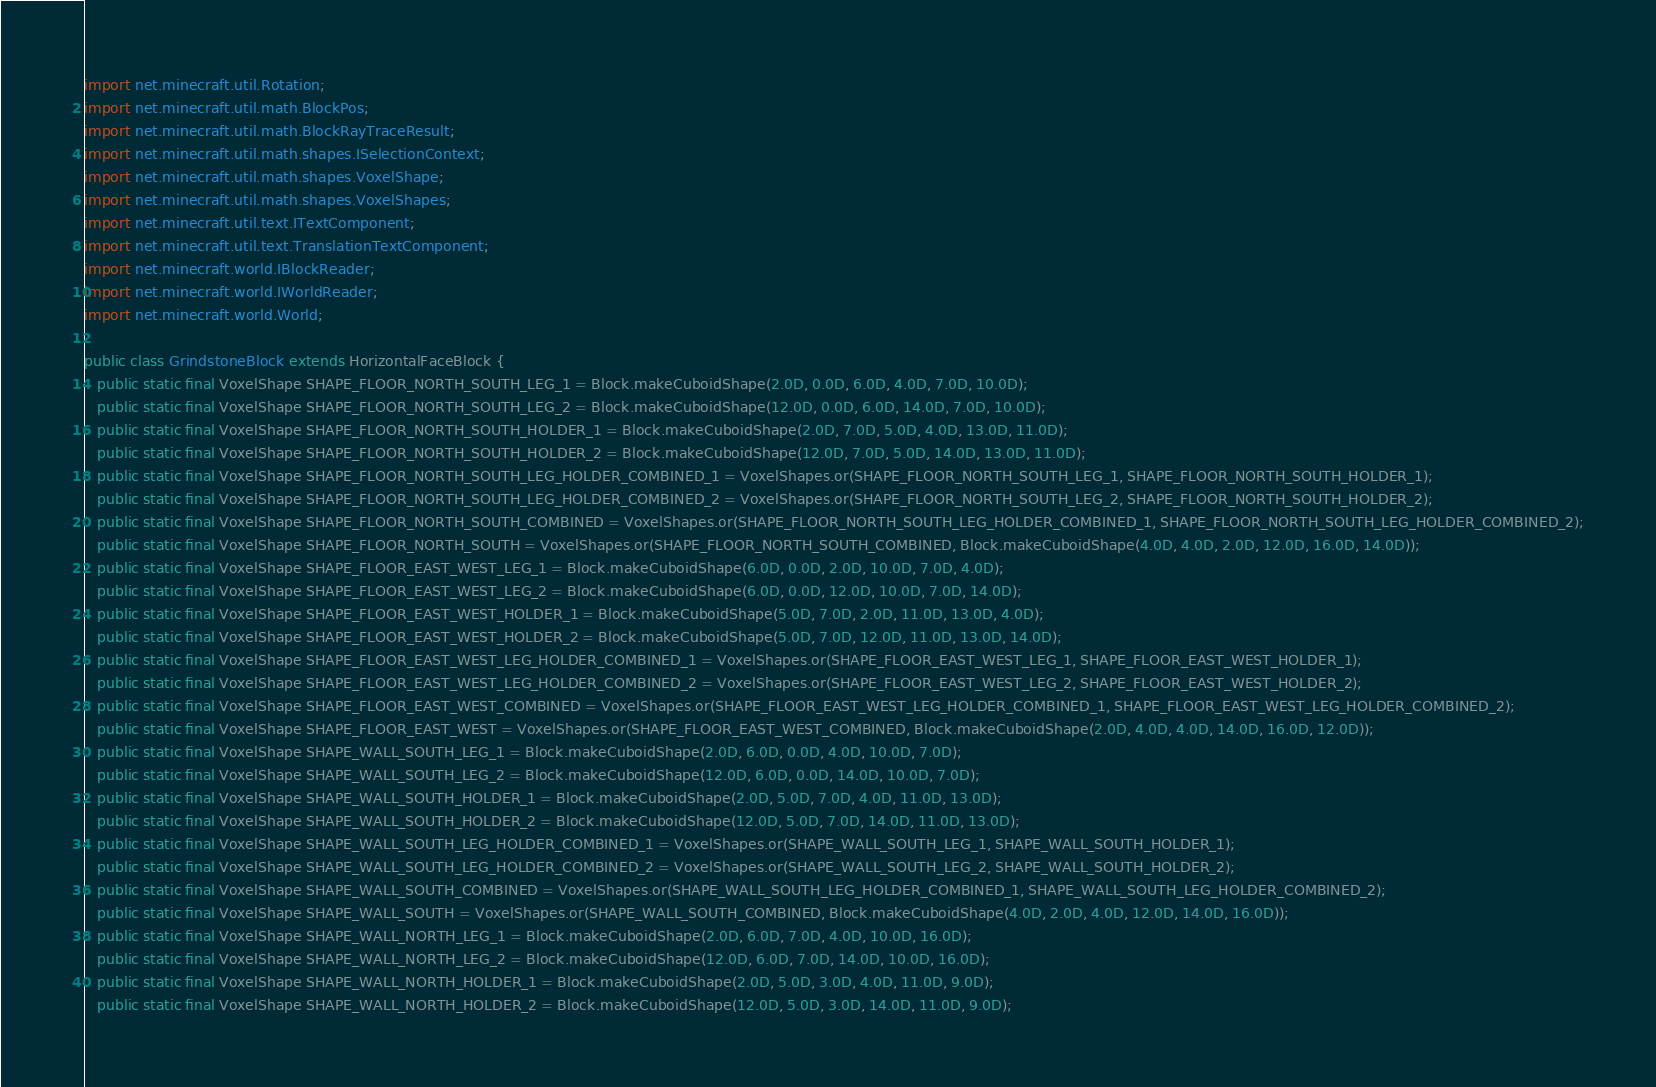Convert code to text. <code><loc_0><loc_0><loc_500><loc_500><_Java_>import net.minecraft.util.Rotation;
import net.minecraft.util.math.BlockPos;
import net.minecraft.util.math.BlockRayTraceResult;
import net.minecraft.util.math.shapes.ISelectionContext;
import net.minecraft.util.math.shapes.VoxelShape;
import net.minecraft.util.math.shapes.VoxelShapes;
import net.minecraft.util.text.ITextComponent;
import net.minecraft.util.text.TranslationTextComponent;
import net.minecraft.world.IBlockReader;
import net.minecraft.world.IWorldReader;
import net.minecraft.world.World;

public class GrindstoneBlock extends HorizontalFaceBlock {
   public static final VoxelShape SHAPE_FLOOR_NORTH_SOUTH_LEG_1 = Block.makeCuboidShape(2.0D, 0.0D, 6.0D, 4.0D, 7.0D, 10.0D);
   public static final VoxelShape SHAPE_FLOOR_NORTH_SOUTH_LEG_2 = Block.makeCuboidShape(12.0D, 0.0D, 6.0D, 14.0D, 7.0D, 10.0D);
   public static final VoxelShape SHAPE_FLOOR_NORTH_SOUTH_HOLDER_1 = Block.makeCuboidShape(2.0D, 7.0D, 5.0D, 4.0D, 13.0D, 11.0D);
   public static final VoxelShape SHAPE_FLOOR_NORTH_SOUTH_HOLDER_2 = Block.makeCuboidShape(12.0D, 7.0D, 5.0D, 14.0D, 13.0D, 11.0D);
   public static final VoxelShape SHAPE_FLOOR_NORTH_SOUTH_LEG_HOLDER_COMBINED_1 = VoxelShapes.or(SHAPE_FLOOR_NORTH_SOUTH_LEG_1, SHAPE_FLOOR_NORTH_SOUTH_HOLDER_1);
   public static final VoxelShape SHAPE_FLOOR_NORTH_SOUTH_LEG_HOLDER_COMBINED_2 = VoxelShapes.or(SHAPE_FLOOR_NORTH_SOUTH_LEG_2, SHAPE_FLOOR_NORTH_SOUTH_HOLDER_2);
   public static final VoxelShape SHAPE_FLOOR_NORTH_SOUTH_COMBINED = VoxelShapes.or(SHAPE_FLOOR_NORTH_SOUTH_LEG_HOLDER_COMBINED_1, SHAPE_FLOOR_NORTH_SOUTH_LEG_HOLDER_COMBINED_2);
   public static final VoxelShape SHAPE_FLOOR_NORTH_SOUTH = VoxelShapes.or(SHAPE_FLOOR_NORTH_SOUTH_COMBINED, Block.makeCuboidShape(4.0D, 4.0D, 2.0D, 12.0D, 16.0D, 14.0D));
   public static final VoxelShape SHAPE_FLOOR_EAST_WEST_LEG_1 = Block.makeCuboidShape(6.0D, 0.0D, 2.0D, 10.0D, 7.0D, 4.0D);
   public static final VoxelShape SHAPE_FLOOR_EAST_WEST_LEG_2 = Block.makeCuboidShape(6.0D, 0.0D, 12.0D, 10.0D, 7.0D, 14.0D);
   public static final VoxelShape SHAPE_FLOOR_EAST_WEST_HOLDER_1 = Block.makeCuboidShape(5.0D, 7.0D, 2.0D, 11.0D, 13.0D, 4.0D);
   public static final VoxelShape SHAPE_FLOOR_EAST_WEST_HOLDER_2 = Block.makeCuboidShape(5.0D, 7.0D, 12.0D, 11.0D, 13.0D, 14.0D);
   public static final VoxelShape SHAPE_FLOOR_EAST_WEST_LEG_HOLDER_COMBINED_1 = VoxelShapes.or(SHAPE_FLOOR_EAST_WEST_LEG_1, SHAPE_FLOOR_EAST_WEST_HOLDER_1);
   public static final VoxelShape SHAPE_FLOOR_EAST_WEST_LEG_HOLDER_COMBINED_2 = VoxelShapes.or(SHAPE_FLOOR_EAST_WEST_LEG_2, SHAPE_FLOOR_EAST_WEST_HOLDER_2);
   public static final VoxelShape SHAPE_FLOOR_EAST_WEST_COMBINED = VoxelShapes.or(SHAPE_FLOOR_EAST_WEST_LEG_HOLDER_COMBINED_1, SHAPE_FLOOR_EAST_WEST_LEG_HOLDER_COMBINED_2);
   public static final VoxelShape SHAPE_FLOOR_EAST_WEST = VoxelShapes.or(SHAPE_FLOOR_EAST_WEST_COMBINED, Block.makeCuboidShape(2.0D, 4.0D, 4.0D, 14.0D, 16.0D, 12.0D));
   public static final VoxelShape SHAPE_WALL_SOUTH_LEG_1 = Block.makeCuboidShape(2.0D, 6.0D, 0.0D, 4.0D, 10.0D, 7.0D);
   public static final VoxelShape SHAPE_WALL_SOUTH_LEG_2 = Block.makeCuboidShape(12.0D, 6.0D, 0.0D, 14.0D, 10.0D, 7.0D);
   public static final VoxelShape SHAPE_WALL_SOUTH_HOLDER_1 = Block.makeCuboidShape(2.0D, 5.0D, 7.0D, 4.0D, 11.0D, 13.0D);
   public static final VoxelShape SHAPE_WALL_SOUTH_HOLDER_2 = Block.makeCuboidShape(12.0D, 5.0D, 7.0D, 14.0D, 11.0D, 13.0D);
   public static final VoxelShape SHAPE_WALL_SOUTH_LEG_HOLDER_COMBINED_1 = VoxelShapes.or(SHAPE_WALL_SOUTH_LEG_1, SHAPE_WALL_SOUTH_HOLDER_1);
   public static final VoxelShape SHAPE_WALL_SOUTH_LEG_HOLDER_COMBINED_2 = VoxelShapes.or(SHAPE_WALL_SOUTH_LEG_2, SHAPE_WALL_SOUTH_HOLDER_2);
   public static final VoxelShape SHAPE_WALL_SOUTH_COMBINED = VoxelShapes.or(SHAPE_WALL_SOUTH_LEG_HOLDER_COMBINED_1, SHAPE_WALL_SOUTH_LEG_HOLDER_COMBINED_2);
   public static final VoxelShape SHAPE_WALL_SOUTH = VoxelShapes.or(SHAPE_WALL_SOUTH_COMBINED, Block.makeCuboidShape(4.0D, 2.0D, 4.0D, 12.0D, 14.0D, 16.0D));
   public static final VoxelShape SHAPE_WALL_NORTH_LEG_1 = Block.makeCuboidShape(2.0D, 6.0D, 7.0D, 4.0D, 10.0D, 16.0D);
   public static final VoxelShape SHAPE_WALL_NORTH_LEG_2 = Block.makeCuboidShape(12.0D, 6.0D, 7.0D, 14.0D, 10.0D, 16.0D);
   public static final VoxelShape SHAPE_WALL_NORTH_HOLDER_1 = Block.makeCuboidShape(2.0D, 5.0D, 3.0D, 4.0D, 11.0D, 9.0D);
   public static final VoxelShape SHAPE_WALL_NORTH_HOLDER_2 = Block.makeCuboidShape(12.0D, 5.0D, 3.0D, 14.0D, 11.0D, 9.0D);</code> 